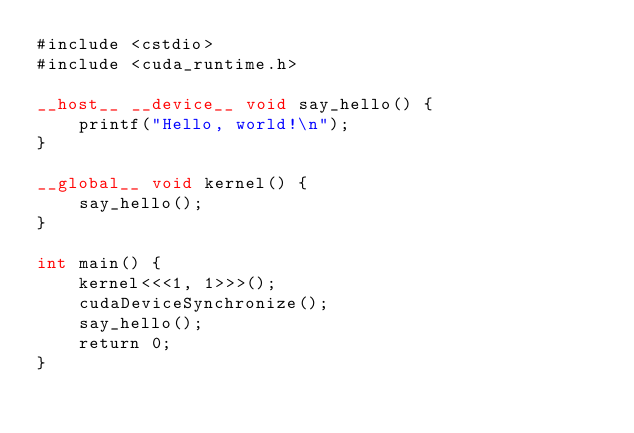Convert code to text. <code><loc_0><loc_0><loc_500><loc_500><_Cuda_>#include <cstdio>
#include <cuda_runtime.h>

__host__ __device__ void say_hello() {
    printf("Hello, world!\n");
}

__global__ void kernel() {
    say_hello();
}

int main() {
    kernel<<<1, 1>>>();
    cudaDeviceSynchronize();
    say_hello();
    return 0;
}
</code> 